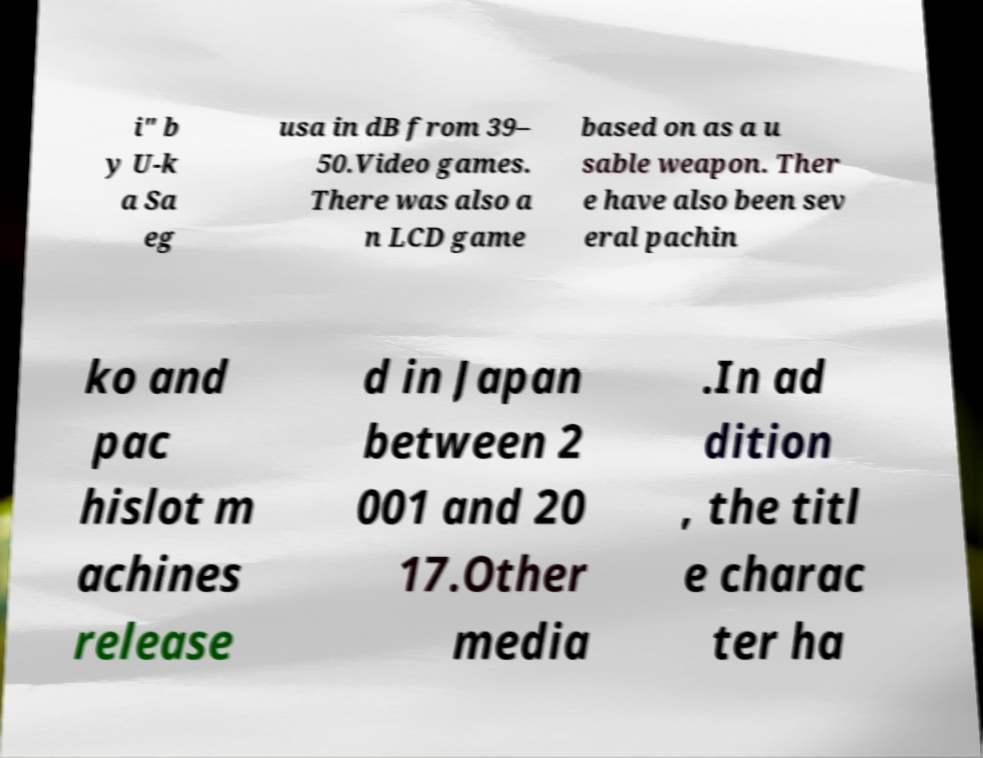What messages or text are displayed in this image? I need them in a readable, typed format. i" b y U-k a Sa eg usa in dB from 39– 50.Video games. There was also a n LCD game based on as a u sable weapon. Ther e have also been sev eral pachin ko and pac hislot m achines release d in Japan between 2 001 and 20 17.Other media .In ad dition , the titl e charac ter ha 